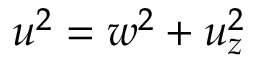<formula> <loc_0><loc_0><loc_500><loc_500>u ^ { 2 } = w ^ { 2 } + u _ { z } ^ { 2 }</formula> 